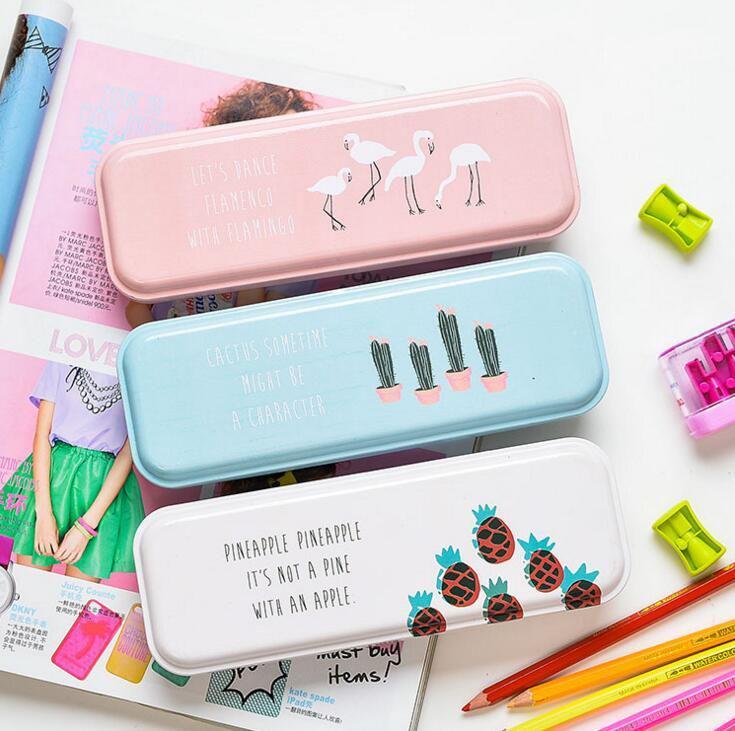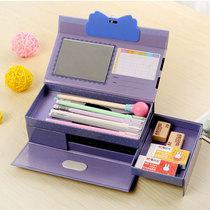The first image is the image on the left, the second image is the image on the right. Considering the images on both sides, is "box shaped pencil holders are folded open" valid? Answer yes or no. Yes. The first image is the image on the left, the second image is the image on the right. Evaluate the accuracy of this statement regarding the images: "The left image contains only closed containers, the right has one open with multiple pencils inside.". Is it true? Answer yes or no. Yes. 